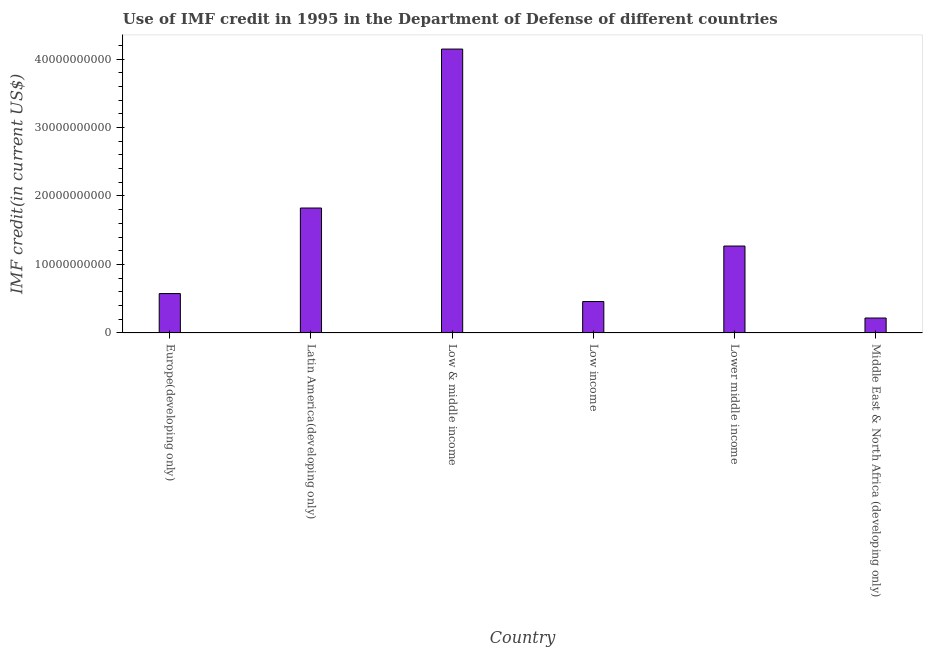Does the graph contain grids?
Your answer should be very brief. No. What is the title of the graph?
Make the answer very short. Use of IMF credit in 1995 in the Department of Defense of different countries. What is the label or title of the X-axis?
Ensure brevity in your answer.  Country. What is the label or title of the Y-axis?
Your answer should be very brief. IMF credit(in current US$). What is the use of imf credit in dod in Lower middle income?
Provide a succinct answer. 1.27e+1. Across all countries, what is the maximum use of imf credit in dod?
Provide a succinct answer. 4.15e+1. Across all countries, what is the minimum use of imf credit in dod?
Your answer should be compact. 2.18e+09. In which country was the use of imf credit in dod minimum?
Ensure brevity in your answer.  Middle East & North Africa (developing only). What is the sum of the use of imf credit in dod?
Give a very brief answer. 8.49e+1. What is the difference between the use of imf credit in dod in Low & middle income and Low income?
Your answer should be very brief. 3.69e+1. What is the average use of imf credit in dod per country?
Ensure brevity in your answer.  1.41e+1. What is the median use of imf credit in dod?
Provide a succinct answer. 9.22e+09. In how many countries, is the use of imf credit in dod greater than 10000000000 US$?
Your response must be concise. 3. What is the ratio of the use of imf credit in dod in Europe(developing only) to that in Low & middle income?
Your response must be concise. 0.14. Is the use of imf credit in dod in Latin America(developing only) less than that in Low income?
Provide a succinct answer. No. Is the difference between the use of imf credit in dod in Latin America(developing only) and Low income greater than the difference between any two countries?
Keep it short and to the point. No. What is the difference between the highest and the second highest use of imf credit in dod?
Keep it short and to the point. 2.32e+1. Is the sum of the use of imf credit in dod in Europe(developing only) and Low income greater than the maximum use of imf credit in dod across all countries?
Your answer should be compact. No. What is the difference between the highest and the lowest use of imf credit in dod?
Your answer should be compact. 3.93e+1. In how many countries, is the use of imf credit in dod greater than the average use of imf credit in dod taken over all countries?
Provide a succinct answer. 2. How many countries are there in the graph?
Your answer should be very brief. 6. What is the IMF credit(in current US$) in Europe(developing only)?
Make the answer very short. 5.75e+09. What is the IMF credit(in current US$) of Latin America(developing only)?
Provide a succinct answer. 1.82e+1. What is the IMF credit(in current US$) in Low & middle income?
Offer a terse response. 4.15e+1. What is the IMF credit(in current US$) of Low income?
Offer a very short reply. 4.59e+09. What is the IMF credit(in current US$) in Lower middle income?
Your answer should be very brief. 1.27e+1. What is the IMF credit(in current US$) of Middle East & North Africa (developing only)?
Give a very brief answer. 2.18e+09. What is the difference between the IMF credit(in current US$) in Europe(developing only) and Latin America(developing only)?
Your answer should be compact. -1.25e+1. What is the difference between the IMF credit(in current US$) in Europe(developing only) and Low & middle income?
Provide a succinct answer. -3.57e+1. What is the difference between the IMF credit(in current US$) in Europe(developing only) and Low income?
Ensure brevity in your answer.  1.16e+09. What is the difference between the IMF credit(in current US$) in Europe(developing only) and Lower middle income?
Keep it short and to the point. -6.94e+09. What is the difference between the IMF credit(in current US$) in Europe(developing only) and Middle East & North Africa (developing only)?
Keep it short and to the point. 3.57e+09. What is the difference between the IMF credit(in current US$) in Latin America(developing only) and Low & middle income?
Your answer should be compact. -2.32e+1. What is the difference between the IMF credit(in current US$) in Latin America(developing only) and Low income?
Offer a terse response. 1.37e+1. What is the difference between the IMF credit(in current US$) in Latin America(developing only) and Lower middle income?
Give a very brief answer. 5.55e+09. What is the difference between the IMF credit(in current US$) in Latin America(developing only) and Middle East & North Africa (developing only)?
Make the answer very short. 1.61e+1. What is the difference between the IMF credit(in current US$) in Low & middle income and Low income?
Provide a short and direct response. 3.69e+1. What is the difference between the IMF credit(in current US$) in Low & middle income and Lower middle income?
Your answer should be compact. 2.88e+1. What is the difference between the IMF credit(in current US$) in Low & middle income and Middle East & North Africa (developing only)?
Offer a terse response. 3.93e+1. What is the difference between the IMF credit(in current US$) in Low income and Lower middle income?
Offer a terse response. -8.10e+09. What is the difference between the IMF credit(in current US$) in Low income and Middle East & North Africa (developing only)?
Offer a very short reply. 2.41e+09. What is the difference between the IMF credit(in current US$) in Lower middle income and Middle East & North Africa (developing only)?
Provide a short and direct response. 1.05e+1. What is the ratio of the IMF credit(in current US$) in Europe(developing only) to that in Latin America(developing only)?
Give a very brief answer. 0.32. What is the ratio of the IMF credit(in current US$) in Europe(developing only) to that in Low & middle income?
Offer a very short reply. 0.14. What is the ratio of the IMF credit(in current US$) in Europe(developing only) to that in Low income?
Offer a very short reply. 1.25. What is the ratio of the IMF credit(in current US$) in Europe(developing only) to that in Lower middle income?
Your answer should be very brief. 0.45. What is the ratio of the IMF credit(in current US$) in Europe(developing only) to that in Middle East & North Africa (developing only)?
Offer a terse response. 2.64. What is the ratio of the IMF credit(in current US$) in Latin America(developing only) to that in Low & middle income?
Provide a short and direct response. 0.44. What is the ratio of the IMF credit(in current US$) in Latin America(developing only) to that in Low income?
Make the answer very short. 3.98. What is the ratio of the IMF credit(in current US$) in Latin America(developing only) to that in Lower middle income?
Your answer should be very brief. 1.44. What is the ratio of the IMF credit(in current US$) in Latin America(developing only) to that in Middle East & North Africa (developing only)?
Offer a very short reply. 8.38. What is the ratio of the IMF credit(in current US$) in Low & middle income to that in Low income?
Give a very brief answer. 9.04. What is the ratio of the IMF credit(in current US$) in Low & middle income to that in Lower middle income?
Give a very brief answer. 3.27. What is the ratio of the IMF credit(in current US$) in Low & middle income to that in Middle East & North Africa (developing only)?
Offer a terse response. 19.04. What is the ratio of the IMF credit(in current US$) in Low income to that in Lower middle income?
Offer a terse response. 0.36. What is the ratio of the IMF credit(in current US$) in Low income to that in Middle East & North Africa (developing only)?
Give a very brief answer. 2.11. What is the ratio of the IMF credit(in current US$) in Lower middle income to that in Middle East & North Africa (developing only)?
Provide a succinct answer. 5.83. 